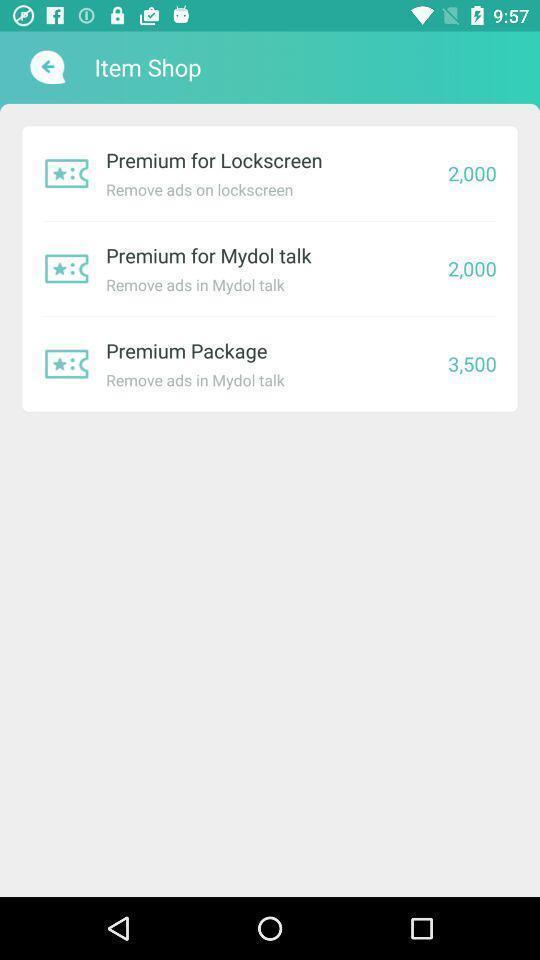What is the overall content of this screenshot? Screen displaying multiple premium packages list with price. 